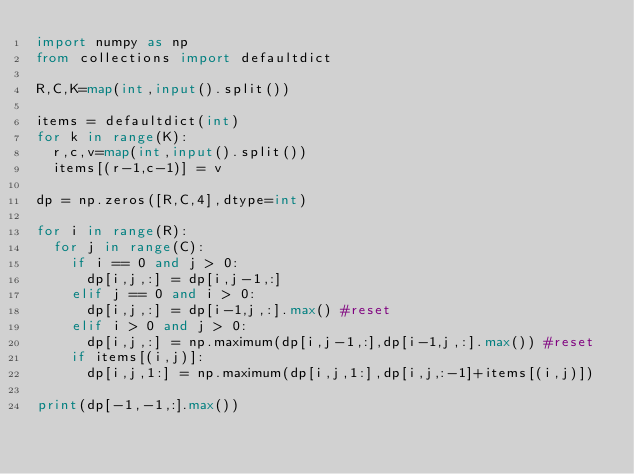<code> <loc_0><loc_0><loc_500><loc_500><_Python_>import numpy as np
from collections import defaultdict

R,C,K=map(int,input().split())

items = defaultdict(int)
for k in range(K):
  r,c,v=map(int,input().split())
  items[(r-1,c-1)] = v

dp = np.zeros([R,C,4],dtype=int)

for i in range(R):
  for j in range(C):
    if i == 0 and j > 0:
      dp[i,j,:] = dp[i,j-1,:]
    elif j == 0 and i > 0:
      dp[i,j,:] = dp[i-1,j,:].max() #reset
    elif i > 0 and j > 0:
      dp[i,j,:] = np.maximum(dp[i,j-1,:],dp[i-1,j,:].max()) #reset
    if items[(i,j)]:
      dp[i,j,1:] = np.maximum(dp[i,j,1:],dp[i,j,:-1]+items[(i,j)])

print(dp[-1,-1,:].max())</code> 